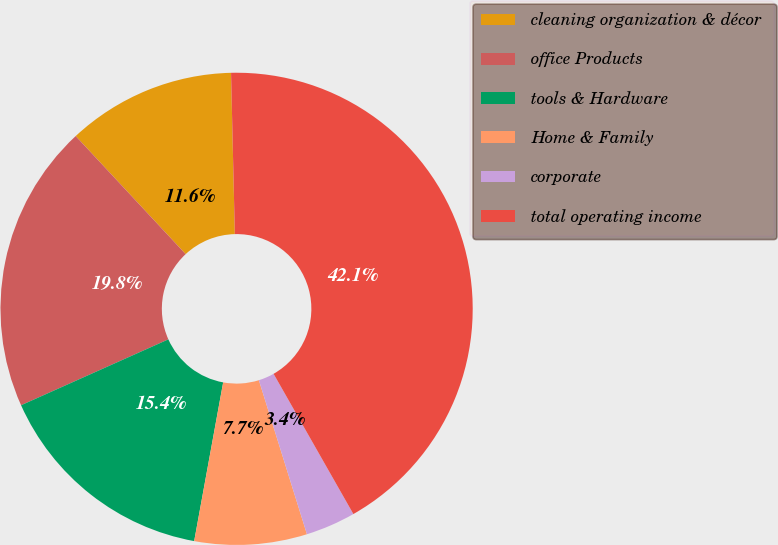Convert chart. <chart><loc_0><loc_0><loc_500><loc_500><pie_chart><fcel>cleaning organization & décor<fcel>office Products<fcel>tools & Hardware<fcel>Home & Family<fcel>corporate<fcel>total operating income<nl><fcel>11.56%<fcel>19.76%<fcel>15.43%<fcel>7.69%<fcel>3.42%<fcel>42.14%<nl></chart> 